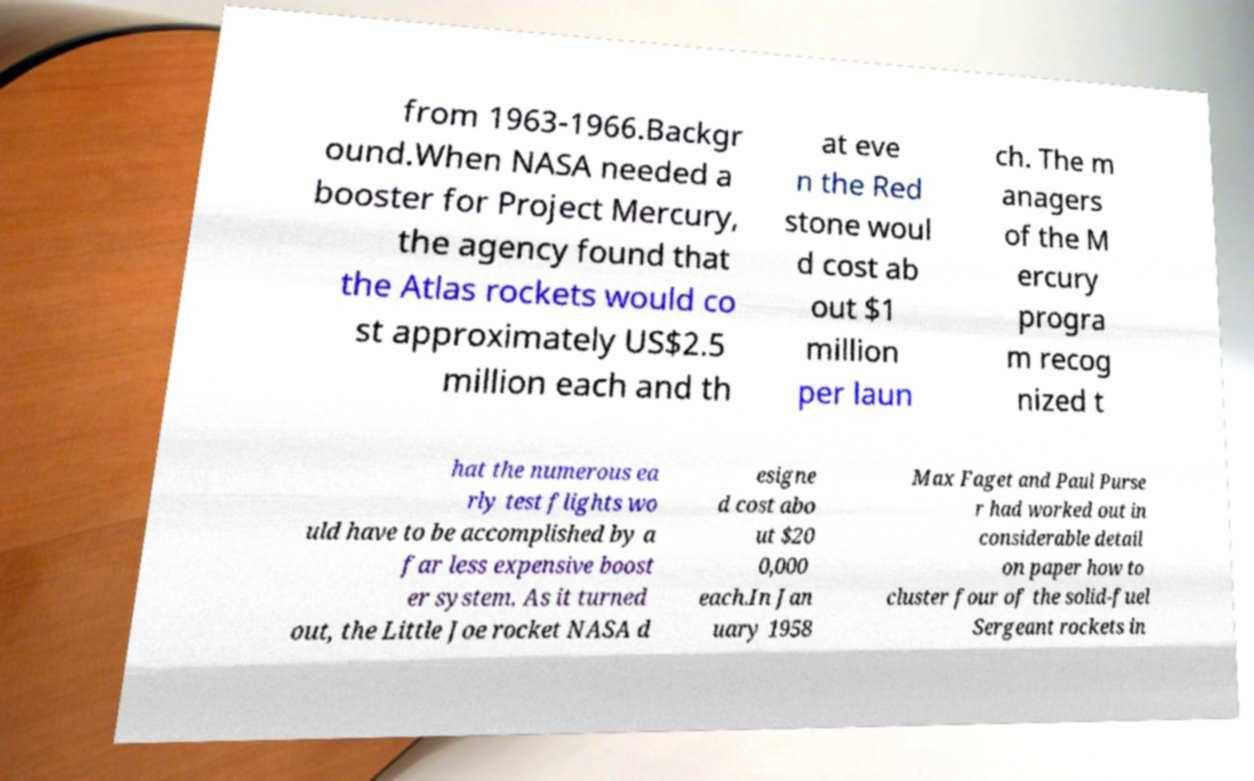I need the written content from this picture converted into text. Can you do that? from 1963-1966.Backgr ound.When NASA needed a booster for Project Mercury, the agency found that the Atlas rockets would co st approximately US$2.5 million each and th at eve n the Red stone woul d cost ab out $1 million per laun ch. The m anagers of the M ercury progra m recog nized t hat the numerous ea rly test flights wo uld have to be accomplished by a far less expensive boost er system. As it turned out, the Little Joe rocket NASA d esigne d cost abo ut $20 0,000 each.In Jan uary 1958 Max Faget and Paul Purse r had worked out in considerable detail on paper how to cluster four of the solid-fuel Sergeant rockets in 